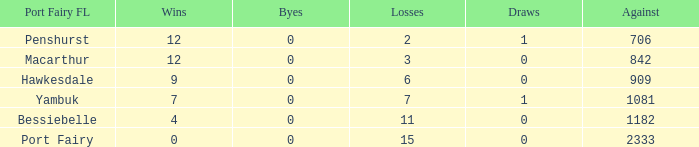How many successes for port fairy and against above 2333? None. 